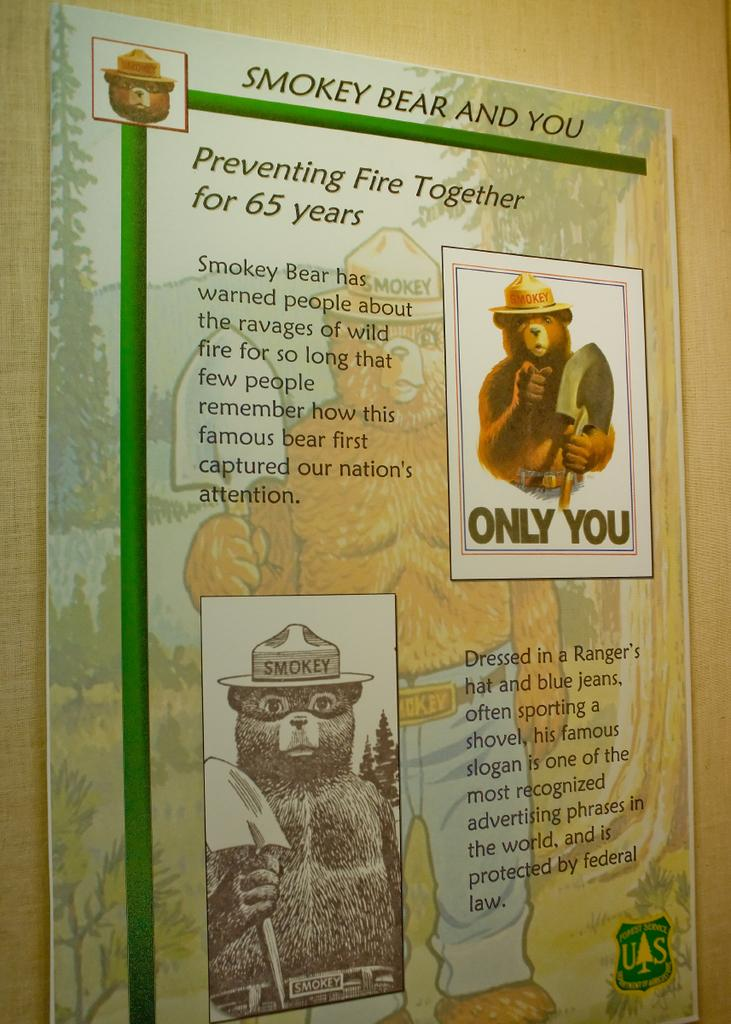<image>
Render a clear and concise summary of the photo. A poster entitled Smoky Bear and You features images of the bear. 